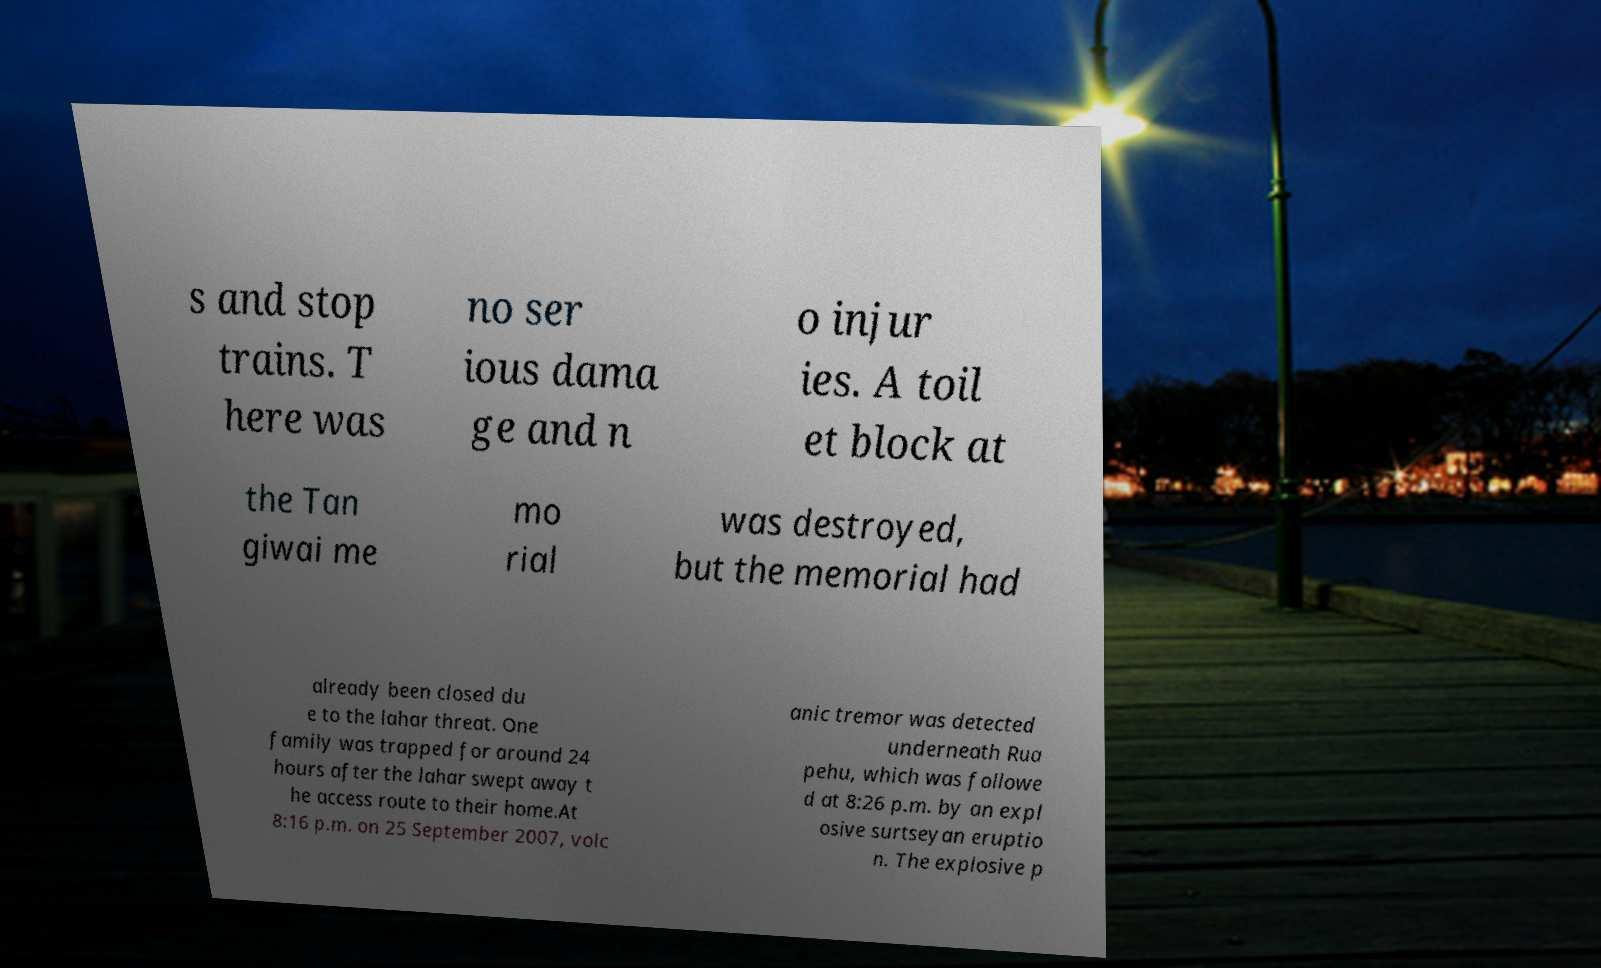What messages or text are displayed in this image? I need them in a readable, typed format. s and stop trains. T here was no ser ious dama ge and n o injur ies. A toil et block at the Tan giwai me mo rial was destroyed, but the memorial had already been closed du e to the lahar threat. One family was trapped for around 24 hours after the lahar swept away t he access route to their home.At 8:16 p.m. on 25 September 2007, volc anic tremor was detected underneath Rua pehu, which was followe d at 8:26 p.m. by an expl osive surtseyan eruptio n. The explosive p 